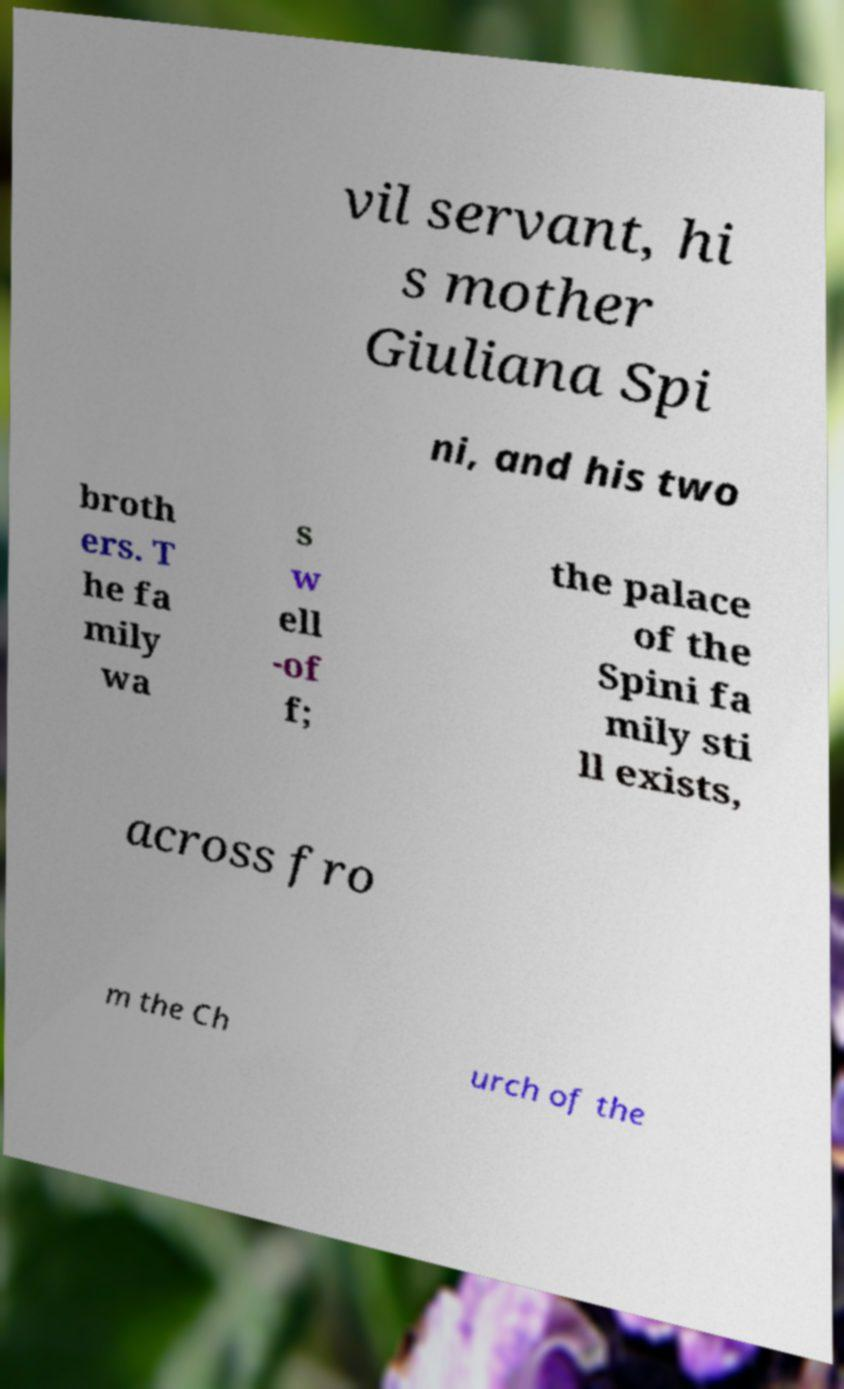For documentation purposes, I need the text within this image transcribed. Could you provide that? vil servant, hi s mother Giuliana Spi ni, and his two broth ers. T he fa mily wa s w ell -of f; the palace of the Spini fa mily sti ll exists, across fro m the Ch urch of the 